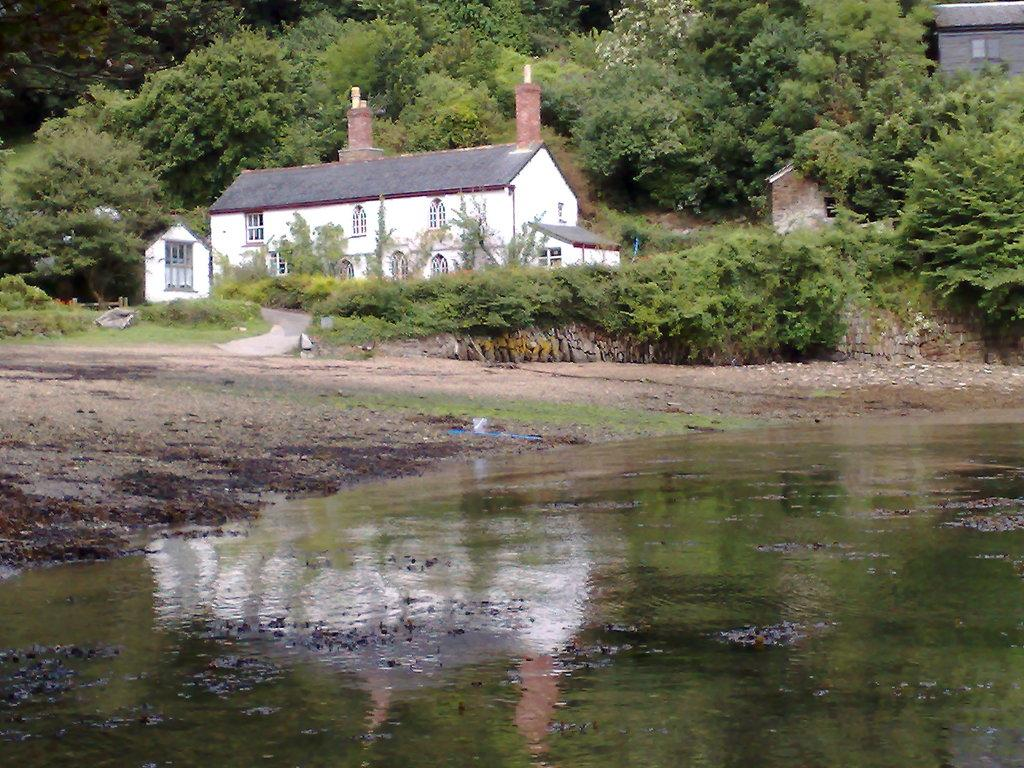What is the primary element present in the image? There is water in the image. What celestial bodies can be seen in the image? There are planets in the image. What type of structures are visible in the image? There are houses in the image. What type of vegetation is present in the image? There are trees in the image. Can you tell me how many firemen are present in the image? There are no firemen present in the image. What type of force is being applied to the planets in the image? There is no indication of any force being applied to the planets in the image. 